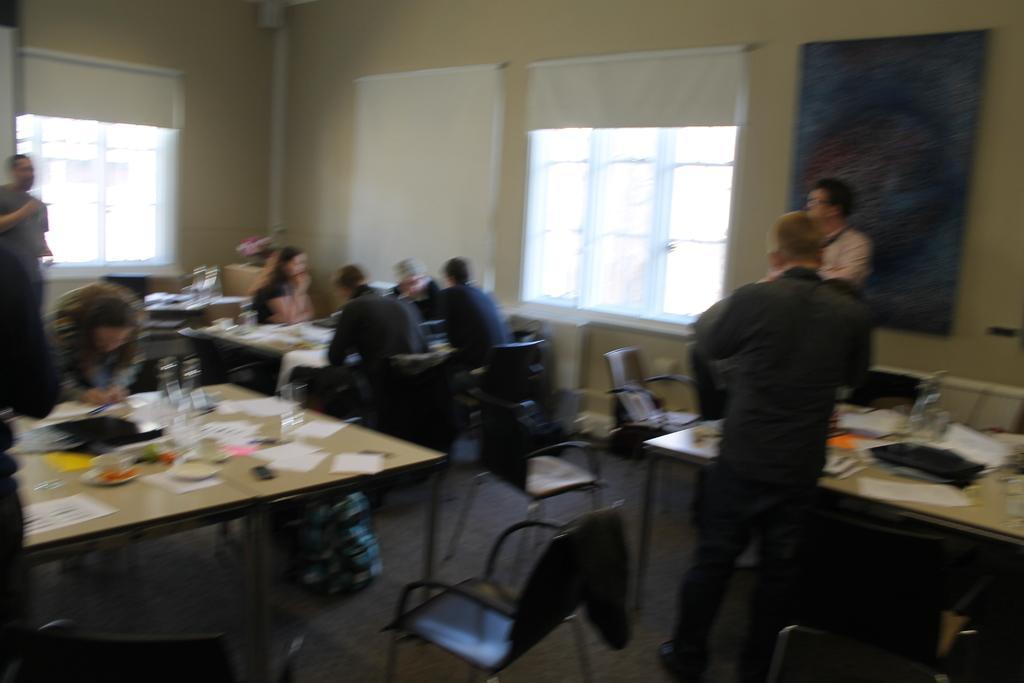Can you describe this image briefly? Few persons sitting on the chair and few persons standing. We can see tables and chairs,on the table we can see things. On the background we can see wall,board,window. This is floor. 